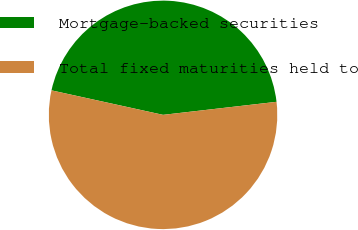Convert chart to OTSL. <chart><loc_0><loc_0><loc_500><loc_500><pie_chart><fcel>Mortgage-backed securities<fcel>Total fixed maturities held to<nl><fcel>44.74%<fcel>55.26%<nl></chart> 